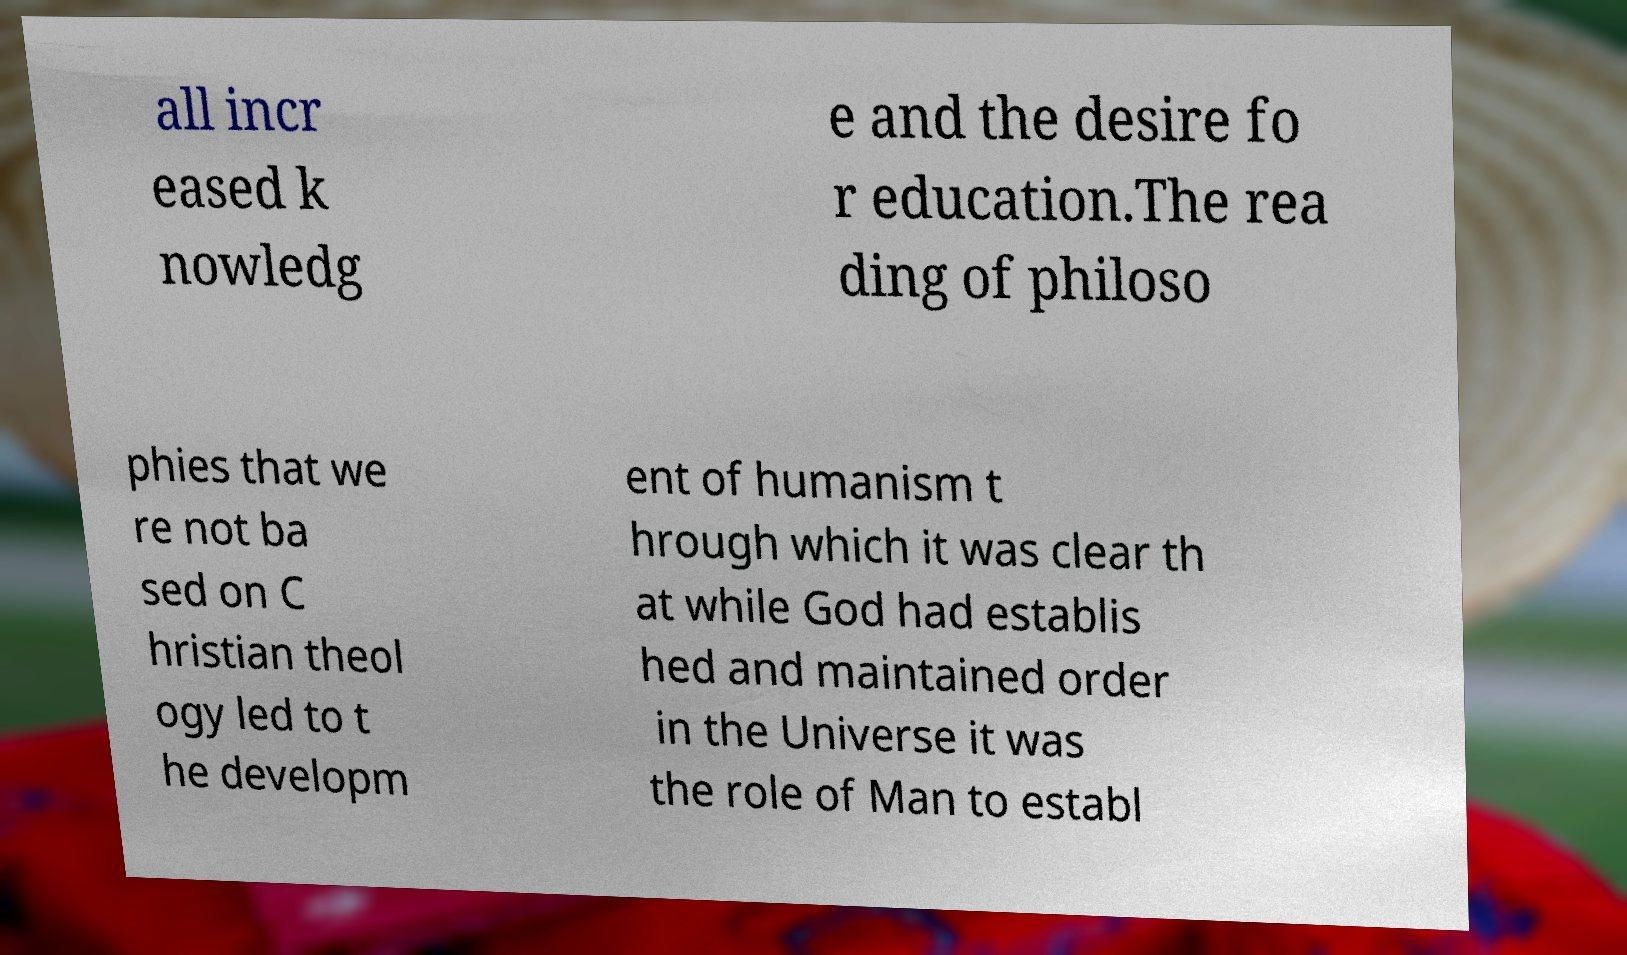What messages or text are displayed in this image? I need them in a readable, typed format. all incr eased k nowledg e and the desire fo r education.The rea ding of philoso phies that we re not ba sed on C hristian theol ogy led to t he developm ent of humanism t hrough which it was clear th at while God had establis hed and maintained order in the Universe it was the role of Man to establ 